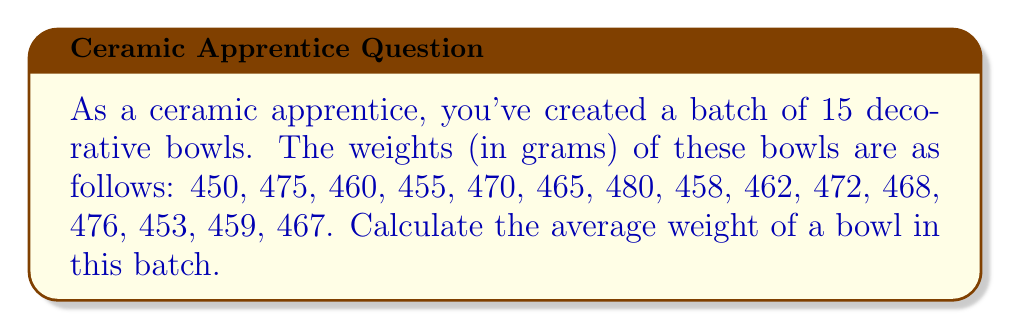Give your solution to this math problem. To calculate the average weight of the ceramic bowls, we need to use the arithmetic mean formula:

$$ \text{Average} = \frac{\text{Sum of all values}}{\text{Number of values}} $$

Let's follow these steps:

1. Sum up all the weights:
   $450 + 475 + 460 + 455 + 470 + 465 + 480 + 458 + 462 + 472 + 468 + 476 + 453 + 459 + 467 = 6970$ grams

2. Count the number of bowls:
   There are 15 bowls in total.

3. Apply the arithmetic mean formula:
   $$ \text{Average weight} = \frac{6970}{15} = 464.6666... \text{ grams} $$

4. Round the result to one decimal place for practical use in ceramics:
   $464.7$ grams

Therefore, the average weight of a bowl in this batch is approximately 464.7 grams.
Answer: $464.7$ grams 